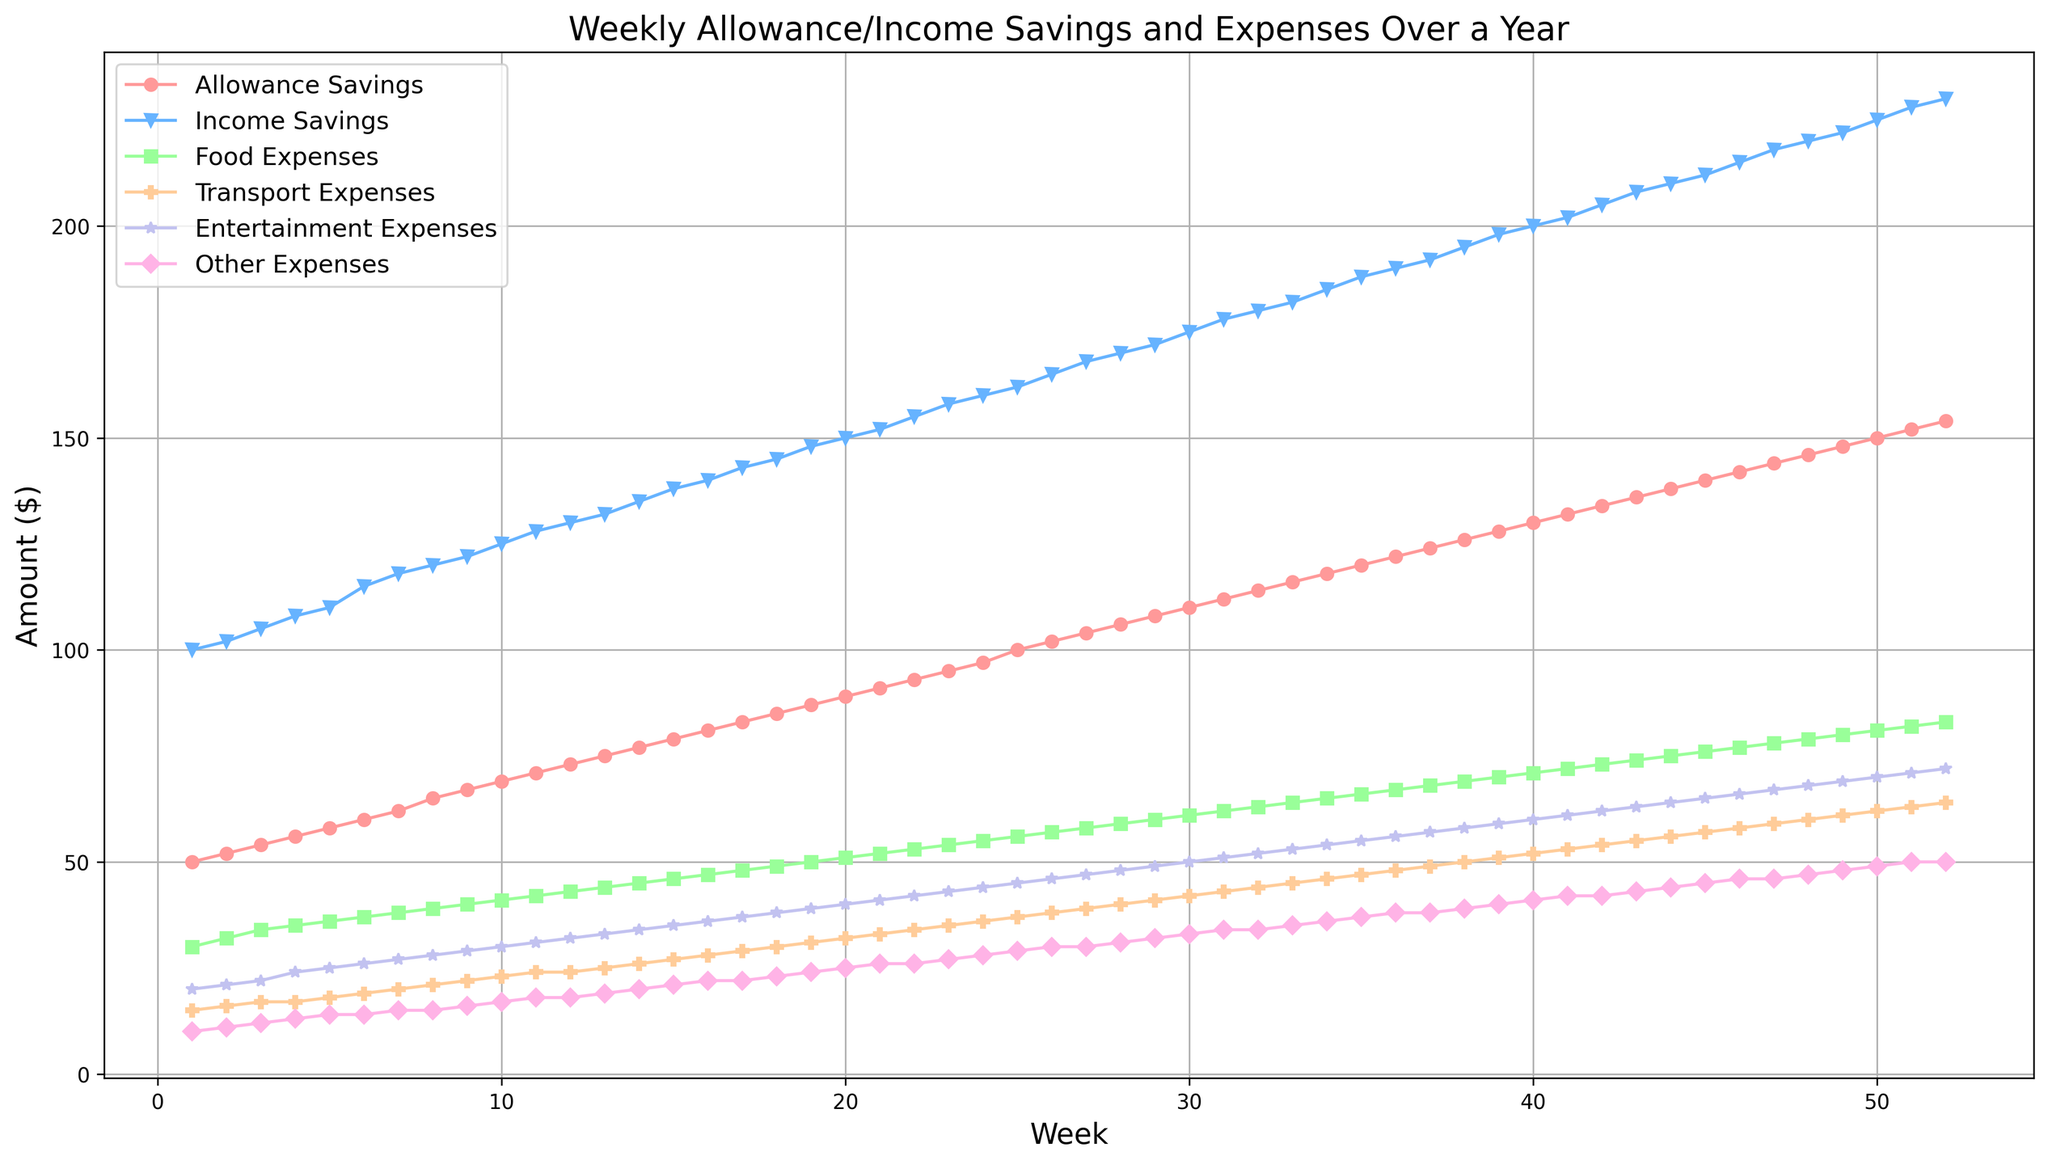What’s the difference between the highest and lowest weekly allowance savings within the year? The highest weekly allowance savings occur in week 52 at $154, and the lowest is in week 1 at $50. The difference is calculated by subtracting the lowest value from the highest value, i.e., $154 - $50 = $104.
Answer: $104 In which week do income savings surpass $200? By looking at the plot, we can see that income savings surpass $200 in week 40, where it reaches $200.
Answer: Week 40 How do food expenses compare to transport expenses in week 20? In week 20, food expenses are $51 and transport expenses are $32. Food expenses are higher than transport expenses by $19.
Answer: Food expenses are higher by $19 Which expense category has the steepest increase over the entire year? By observing the slope of the lines in the plot, it is clear that entertainment expenses have the steepest slope, indicating the highest increase over the year.
Answer: Entertainment Expenses What is the combined total of transport and entertainment expenses in week 10? Transport expenses in week 10 are $23, and entertainment expenses are $30. Their combined total is calculated as $23 + $30 = $53.
Answer: $53 What color represents "Other Expenses" in the plot? The color representing "Other Expenses" in the plot is pink. This can be identified by matching the color of the line to the legend in the figure.
Answer: Pink During which week do allowance savings reach exactly $100? The allowance savings reach exactly $100 in week 25. This can be inferred by looking at the plot where the "Allowance Savings" line hits the $100 mark.
Answer: Week 25 Which week shows the highest difference between income savings and allowance savings? The highest difference between income savings and allowance savings occurs in week 52. Income savings are $230, and allowance savings are $154, leading to a difference of $230 - $154 = $76.
Answer: Week 52 What’s the average food expense over the first 5 weeks? The food expenses over the first 5 weeks are $30, $32, $34, $35, and $36. The average is calculated as (30 + 32 + 34 + 35 + 36) / 5 = 33.4.
Answer: $33.4 Which category has the least growth from week 1 to week 52? By examining the plot, it is apparent that other expenses have the smallest increase, growing from $10 in week 1 to $50 in week 52, which is an increase of $40.
Answer: Other Expenses 